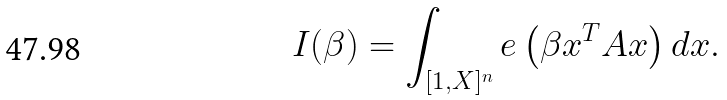Convert formula to latex. <formula><loc_0><loc_0><loc_500><loc_500>I ( \beta ) = \int _ { [ 1 , X ] ^ { n } } e \left ( \beta x ^ { T } A x \right ) d x .</formula> 